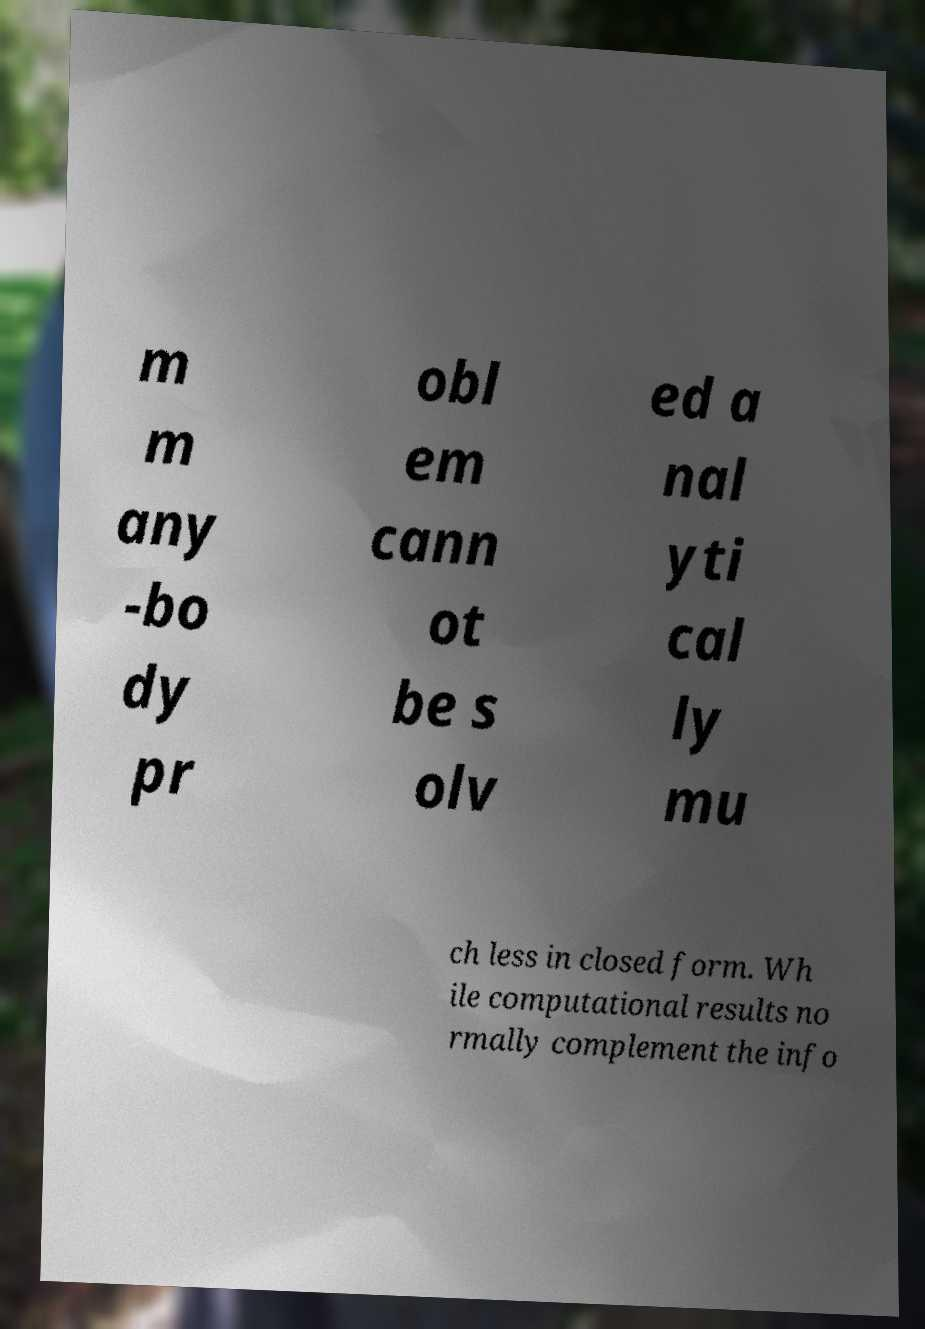Could you extract and type out the text from this image? m m any -bo dy pr obl em cann ot be s olv ed a nal yti cal ly mu ch less in closed form. Wh ile computational results no rmally complement the info 